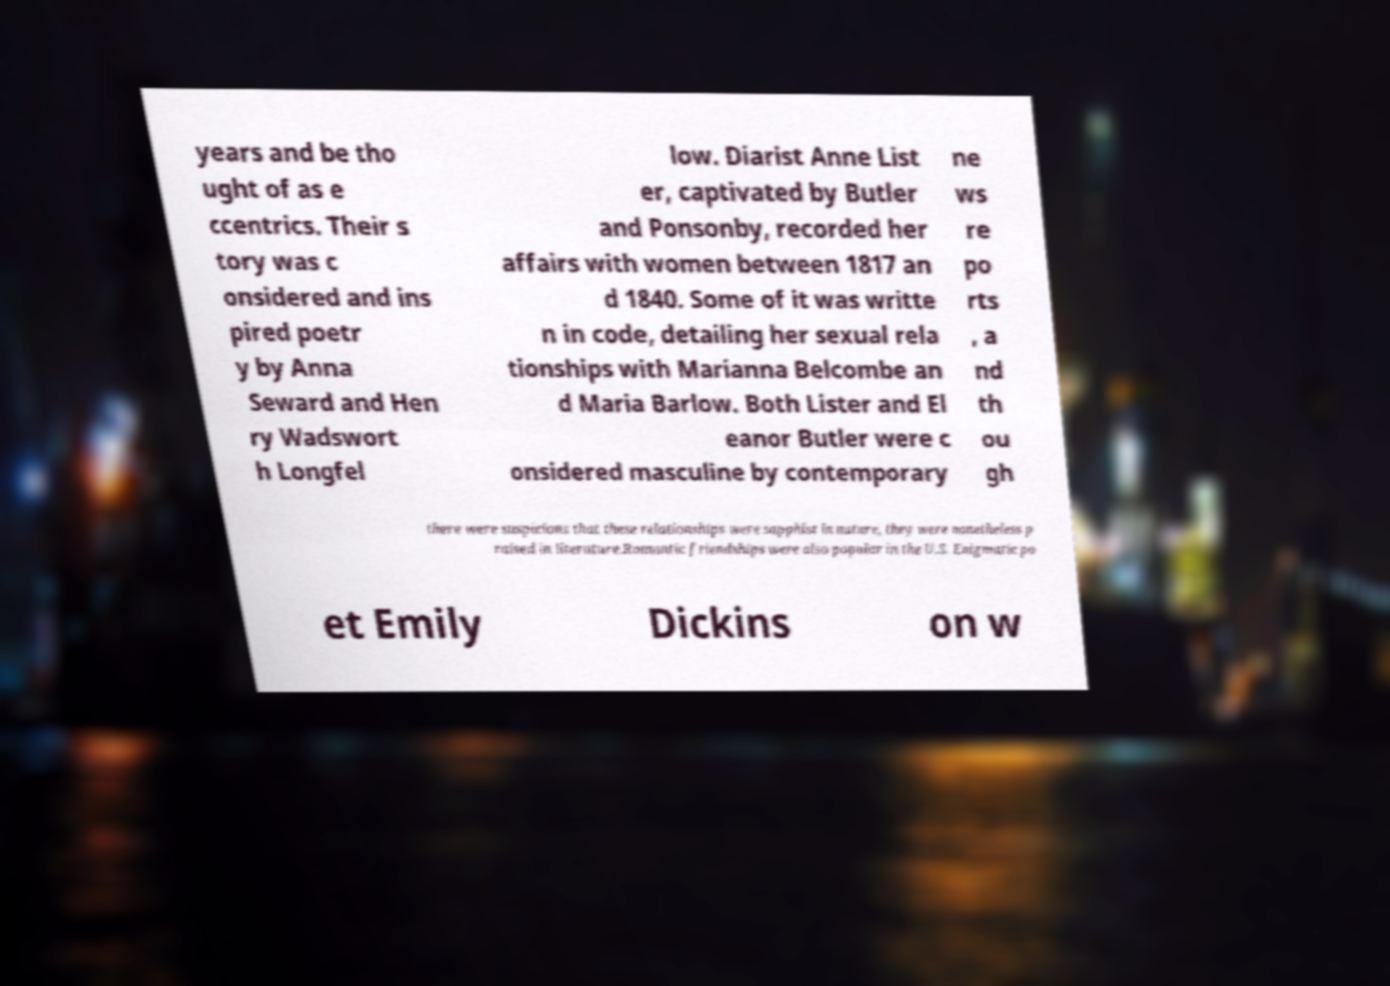Can you accurately transcribe the text from the provided image for me? years and be tho ught of as e ccentrics. Their s tory was c onsidered and ins pired poetr y by Anna Seward and Hen ry Wadswort h Longfel low. Diarist Anne List er, captivated by Butler and Ponsonby, recorded her affairs with women between 1817 an d 1840. Some of it was writte n in code, detailing her sexual rela tionships with Marianna Belcombe an d Maria Barlow. Both Lister and El eanor Butler were c onsidered masculine by contemporary ne ws re po rts , a nd th ou gh there were suspicions that these relationships were sapphist in nature, they were nonetheless p raised in literature.Romantic friendships were also popular in the U.S. Enigmatic po et Emily Dickins on w 